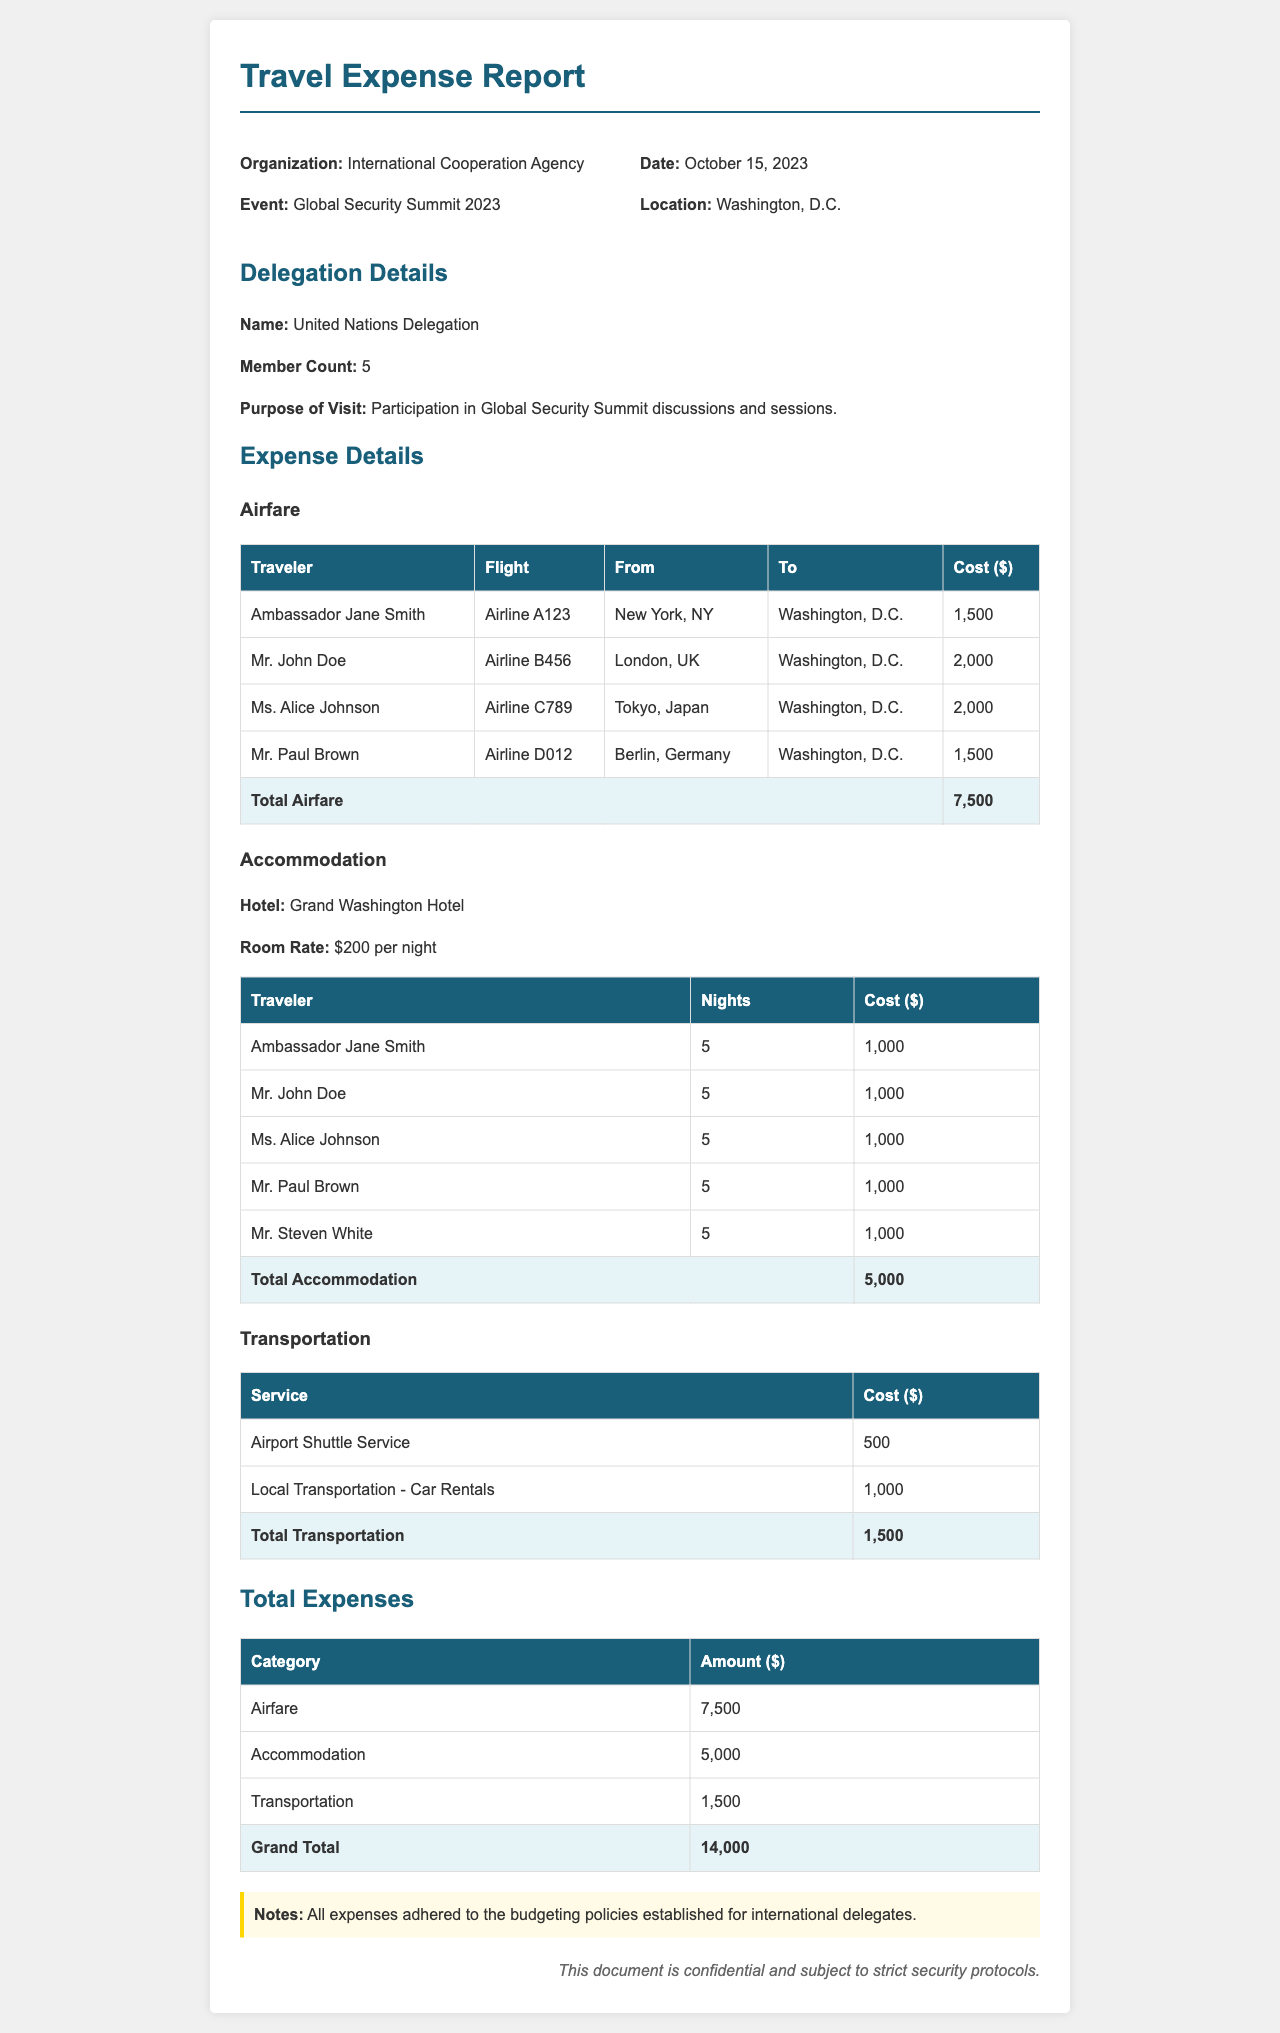What is the total airfare cost? The total airfare cost is the sum of all individual airfare costs listed in the document, which equals $1,500 + $2,000 + $2,000 + $1,500 = $7,500.
Answer: $7,500 What is the purpose of the visit for the United Nations Delegation? The document states that the purpose of the visit is "Participation in Global Security Summit discussions and sessions."
Answer: Participation in Global Security Summit discussions and sessions How many nights did each traveler stay at the hotel? It is stated in the accommodation section that each traveler, including Ambassador Jane Smith, Mr. John Doe, Ms. Alice Johnson, Mr. Paul Brown, and Mr. Steven White, stayed for 5 nights.
Answer: 5 What is the total cost for local transportation car rentals? The total cost for local transportation is specified in the transportation section, which lists it as $1,000.
Answer: $1,000 What is the grand total of all expenses? The grand total is calculated by summing all the totals from airfare, accommodation, and transportation, resulting in $7,500 + $5,000 + $1,500 = $14,000.
Answer: $14,000 Which hotel was used for accommodation? The document specifies that the hotel used for accommodation is the "Grand Washington Hotel."
Answer: Grand Washington Hotel How many members are in the United Nations Delegation? The details in the document indicate that the United Nations Delegation consists of 5 members.
Answer: 5 What service corresponds to the cost of $500? The transportation section describes "Airport Shuttle Service" with a cost of $500.
Answer: Airport Shuttle Service What is stated in the notes regarding expenses? The notes indicate that "All expenses adhered to the budgeting policies established for international delegates."
Answer: All expenses adhered to the budgeting policies established for international delegates 